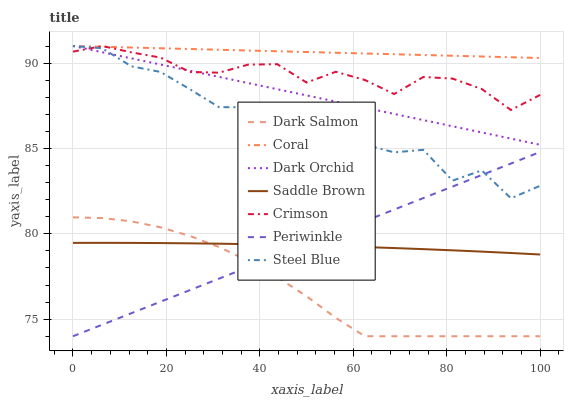Does Dark Salmon have the minimum area under the curve?
Answer yes or no. Yes. Does Coral have the maximum area under the curve?
Answer yes or no. Yes. Does Dark Orchid have the minimum area under the curve?
Answer yes or no. No. Does Dark Orchid have the maximum area under the curve?
Answer yes or no. No. Is Periwinkle the smoothest?
Answer yes or no. Yes. Is Steel Blue the roughest?
Answer yes or no. Yes. Is Dark Salmon the smoothest?
Answer yes or no. No. Is Dark Salmon the roughest?
Answer yes or no. No. Does Dark Orchid have the lowest value?
Answer yes or no. No. Does Dark Salmon have the highest value?
Answer yes or no. No. Is Periwinkle less than Coral?
Answer yes or no. Yes. Is Dark Orchid greater than Dark Salmon?
Answer yes or no. Yes. Does Periwinkle intersect Coral?
Answer yes or no. No. 